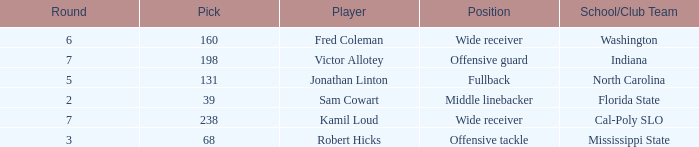Which Round has a School/Club Team of indiana, and a Pick smaller than 198? None. Help me parse the entirety of this table. {'header': ['Round', 'Pick', 'Player', 'Position', 'School/Club Team'], 'rows': [['6', '160', 'Fred Coleman', 'Wide receiver', 'Washington'], ['7', '198', 'Victor Allotey', 'Offensive guard', 'Indiana'], ['5', '131', 'Jonathan Linton', 'Fullback', 'North Carolina'], ['2', '39', 'Sam Cowart', 'Middle linebacker', 'Florida State'], ['7', '238', 'Kamil Loud', 'Wide receiver', 'Cal-Poly SLO'], ['3', '68', 'Robert Hicks', 'Offensive tackle', 'Mississippi State']]} 